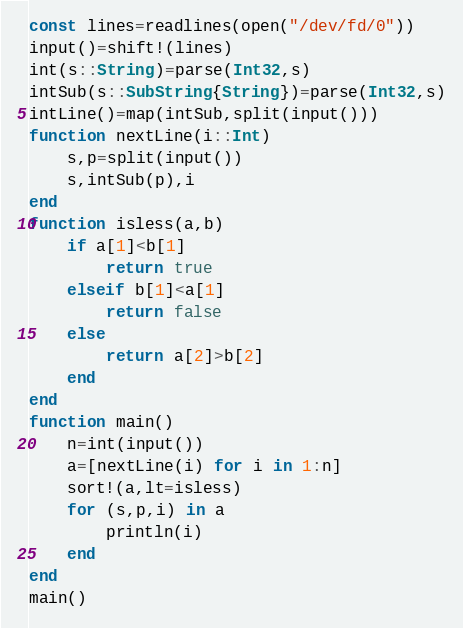<code> <loc_0><loc_0><loc_500><loc_500><_Julia_>const lines=readlines(open("/dev/fd/0"))
input()=shift!(lines)
int(s::String)=parse(Int32,s)
intSub(s::SubString{String})=parse(Int32,s)
intLine()=map(intSub,split(input()))
function nextLine(i::Int)
    s,p=split(input())
    s,intSub(p),i
end
function isless(a,b)
    if a[1]<b[1]
        return true
    elseif b[1]<a[1]
        return false
    else
        return a[2]>b[2]
    end
end
function main()
    n=int(input())
    a=[nextLine(i) for i in 1:n]
    sort!(a,lt=isless)
    for (s,p,i) in a
        println(i)
    end
end
main()</code> 